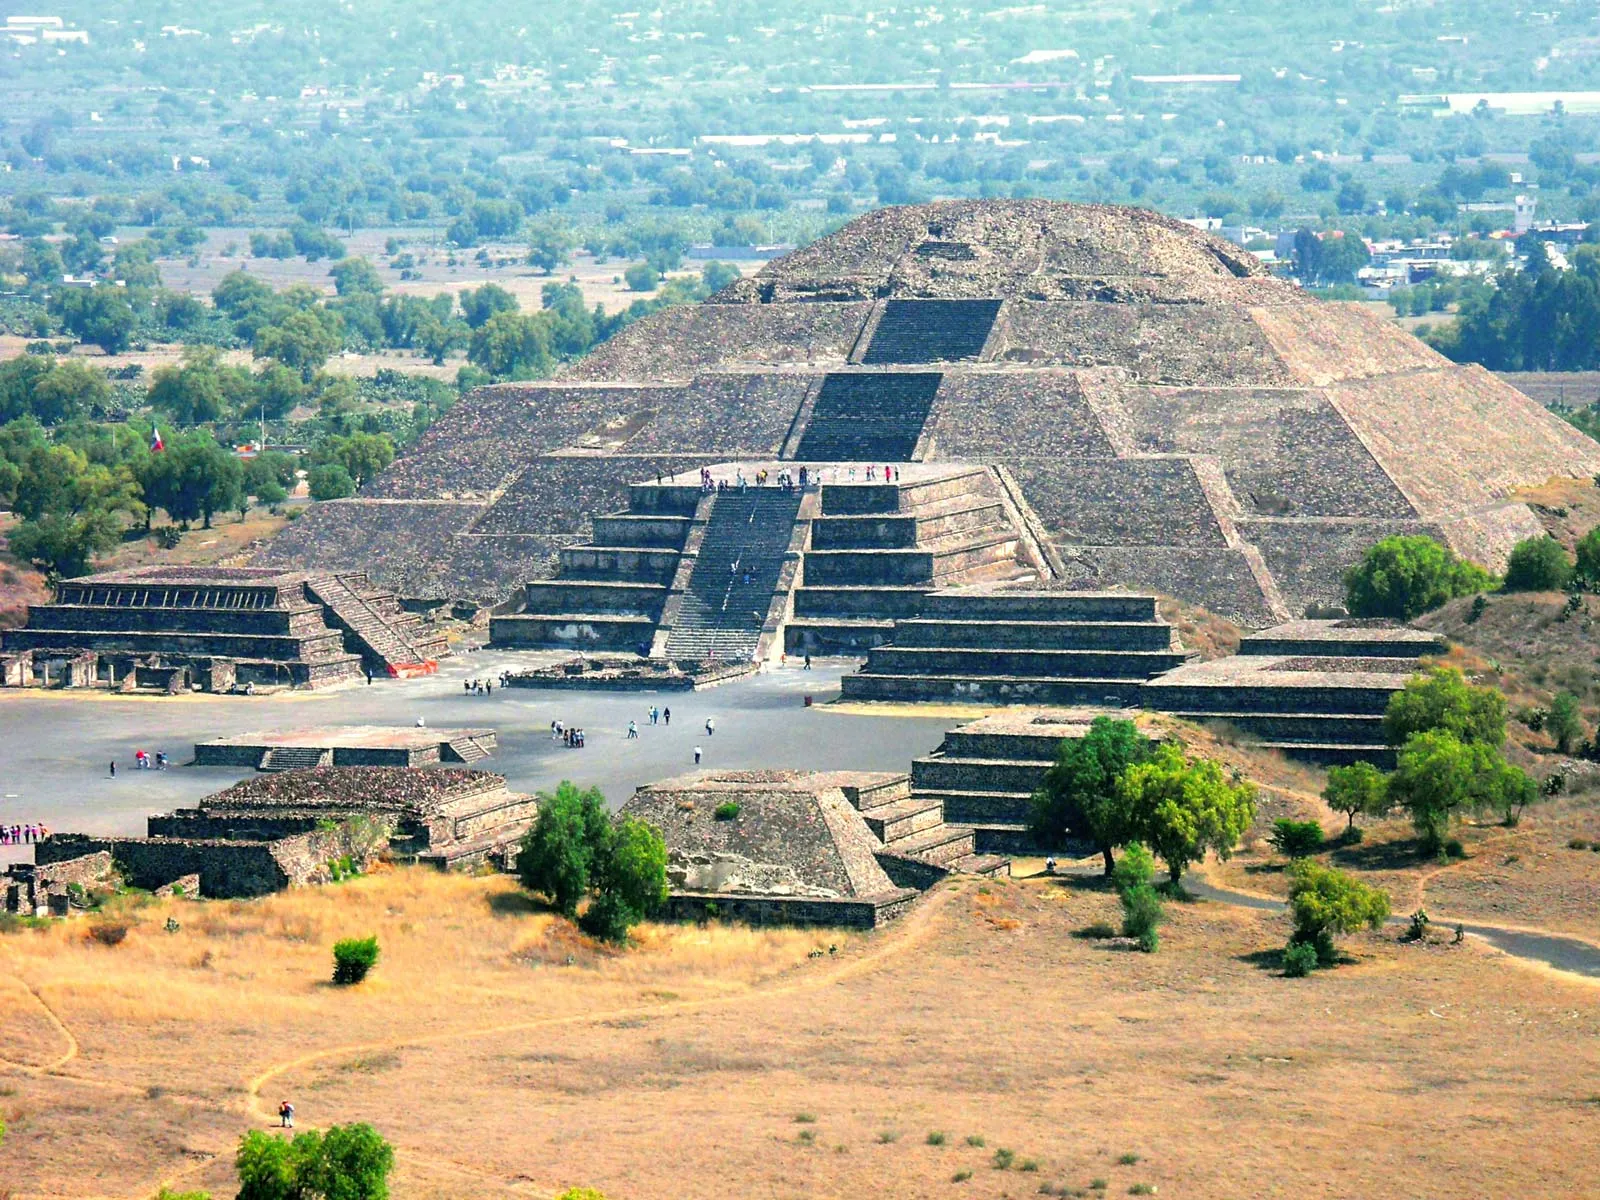In a parallel universe, what could this pyramid be used for? In a parallel universe, the Pyramid of the Sun might serve as the central hub of an interstellar communications network. Instead of being a religious or ceremonial site, it could be a futuristic beacon transmitting and receiving signals from distant galaxies. The pyramid’s steps could be equipped with advanced technology, like antennae and solar panels, converting the ancient structure into a space-age marvel. In this universe, the pyramid might be surrounded not by smaller stone buildings but by sleek, floating platforms where scientists and explorers from various worlds gather to exchange knowledge. The lush greenery around might be replaced by gardens of alien flora, creating a vibrant and otherworldly scene. This pyramid, a symbol of intergalactic unity, could embody the collaboration between ancient wisdom and futuristic innovation. 